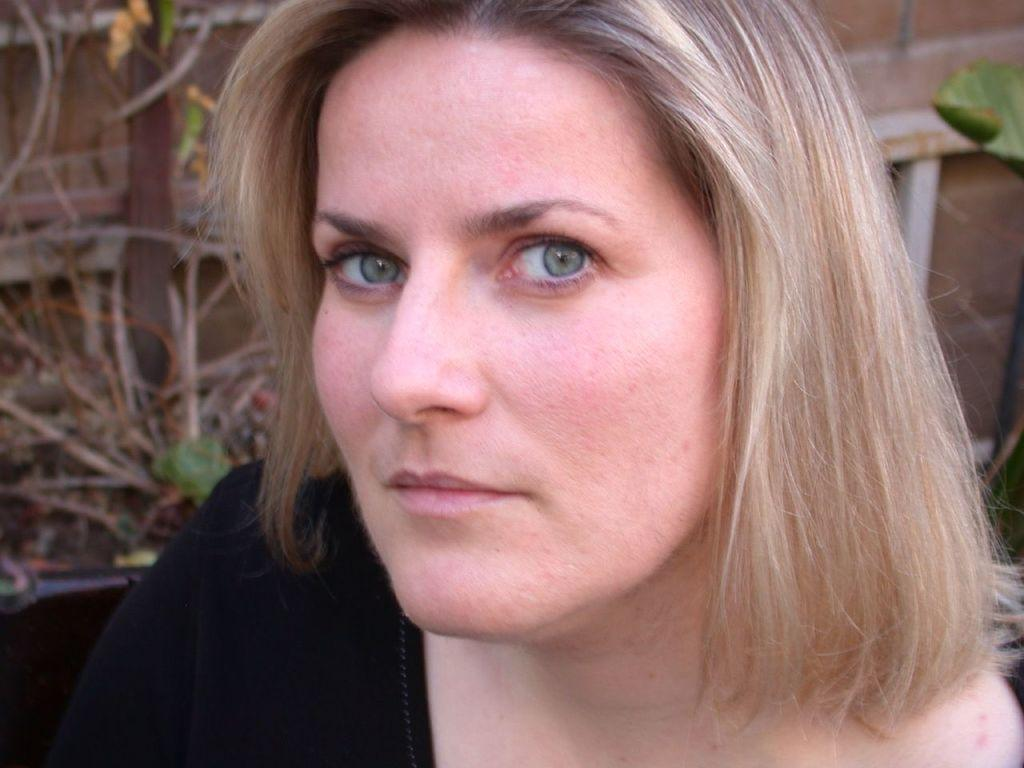Who is in the image? There is a woman in the image. What is the woman wearing? The woman is wearing a black dress. What is the woman doing in the image? The woman is watching something. What can be seen in the background of the image? There is a wall in the background of the image. What type of vegetation is present in the image? Leaves are present in the image. What type of objects can be seen in the image? Rods are visible in the image, and there are other objects as well. What type of bead is the writer using to create a line in the image? There is no writer or bead present in the image. The woman is watching something, but there is no indication of any writing or beads. 